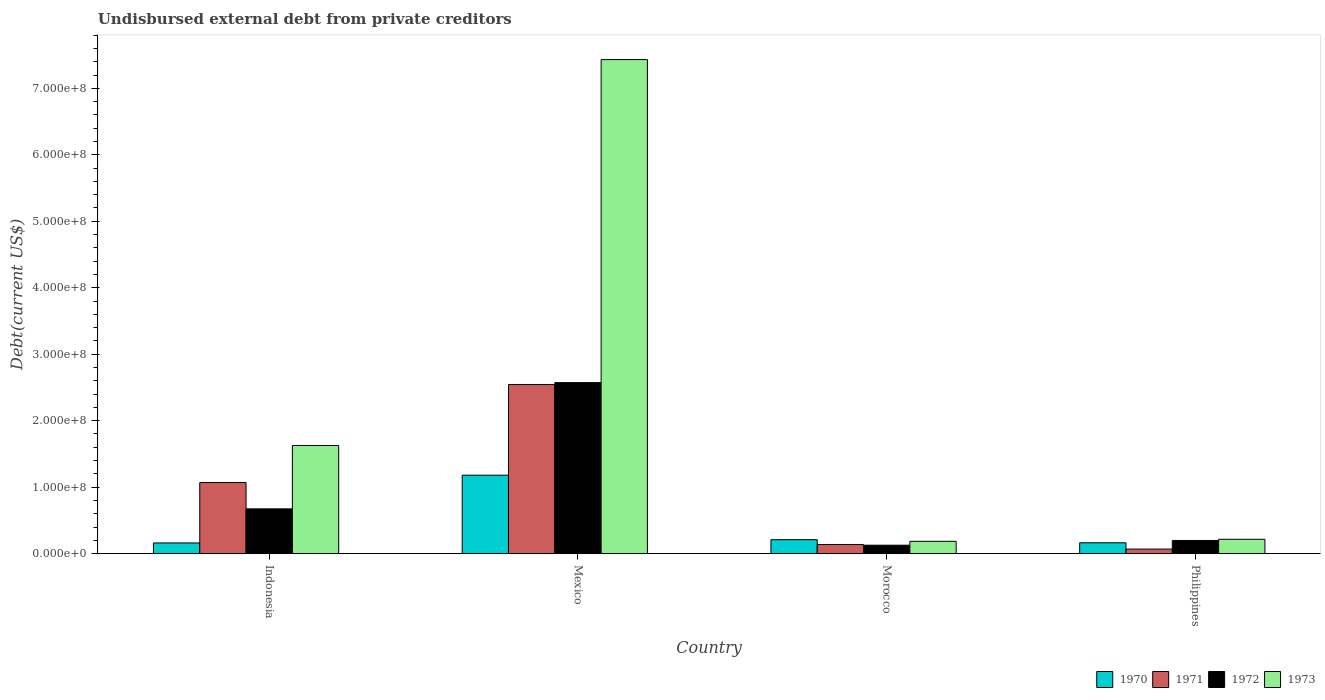Are the number of bars per tick equal to the number of legend labels?
Make the answer very short. Yes. Are the number of bars on each tick of the X-axis equal?
Offer a very short reply. Yes. How many bars are there on the 2nd tick from the right?
Your answer should be very brief. 4. What is the label of the 1st group of bars from the left?
Your answer should be compact. Indonesia. What is the total debt in 1970 in Indonesia?
Offer a very short reply. 1.61e+07. Across all countries, what is the maximum total debt in 1971?
Provide a short and direct response. 2.54e+08. Across all countries, what is the minimum total debt in 1973?
Offer a terse response. 1.86e+07. In which country was the total debt in 1973 maximum?
Provide a succinct answer. Mexico. What is the total total debt in 1972 in the graph?
Ensure brevity in your answer.  3.57e+08. What is the difference between the total debt in 1972 in Indonesia and that in Philippines?
Offer a very short reply. 4.75e+07. What is the difference between the total debt in 1971 in Indonesia and the total debt in 1973 in Mexico?
Give a very brief answer. -6.36e+08. What is the average total debt in 1970 per country?
Ensure brevity in your answer.  4.29e+07. What is the difference between the total debt of/in 1973 and total debt of/in 1971 in Morocco?
Keep it short and to the point. 4.81e+06. In how many countries, is the total debt in 1970 greater than 40000000 US$?
Your answer should be compact. 1. What is the ratio of the total debt in 1972 in Indonesia to that in Philippines?
Make the answer very short. 3.39. What is the difference between the highest and the second highest total debt in 1971?
Your answer should be compact. 2.41e+08. What is the difference between the highest and the lowest total debt in 1970?
Offer a very short reply. 1.02e+08. Is the sum of the total debt in 1970 in Mexico and Philippines greater than the maximum total debt in 1972 across all countries?
Make the answer very short. No. Is it the case that in every country, the sum of the total debt in 1972 and total debt in 1973 is greater than the sum of total debt in 1970 and total debt in 1971?
Offer a terse response. Yes. What does the 1st bar from the left in Philippines represents?
Your answer should be very brief. 1970. What does the 2nd bar from the right in Philippines represents?
Your response must be concise. 1972. How many bars are there?
Your answer should be very brief. 16. Are all the bars in the graph horizontal?
Provide a short and direct response. No. Are the values on the major ticks of Y-axis written in scientific E-notation?
Offer a very short reply. Yes. How are the legend labels stacked?
Your answer should be very brief. Horizontal. What is the title of the graph?
Your answer should be compact. Undisbursed external debt from private creditors. Does "1974" appear as one of the legend labels in the graph?
Provide a succinct answer. No. What is the label or title of the X-axis?
Your response must be concise. Country. What is the label or title of the Y-axis?
Your answer should be very brief. Debt(current US$). What is the Debt(current US$) of 1970 in Indonesia?
Offer a very short reply. 1.61e+07. What is the Debt(current US$) of 1971 in Indonesia?
Ensure brevity in your answer.  1.07e+08. What is the Debt(current US$) of 1972 in Indonesia?
Offer a very short reply. 6.74e+07. What is the Debt(current US$) of 1973 in Indonesia?
Offer a very short reply. 1.63e+08. What is the Debt(current US$) of 1970 in Mexico?
Give a very brief answer. 1.18e+08. What is the Debt(current US$) in 1971 in Mexico?
Keep it short and to the point. 2.54e+08. What is the Debt(current US$) of 1972 in Mexico?
Offer a very short reply. 2.57e+08. What is the Debt(current US$) of 1973 in Mexico?
Offer a very short reply. 7.43e+08. What is the Debt(current US$) of 1970 in Morocco?
Keep it short and to the point. 2.10e+07. What is the Debt(current US$) of 1971 in Morocco?
Your answer should be compact. 1.37e+07. What is the Debt(current US$) of 1972 in Morocco?
Make the answer very short. 1.27e+07. What is the Debt(current US$) of 1973 in Morocco?
Offer a very short reply. 1.86e+07. What is the Debt(current US$) of 1970 in Philippines?
Make the answer very short. 1.64e+07. What is the Debt(current US$) in 1971 in Philippines?
Your response must be concise. 6.87e+06. What is the Debt(current US$) of 1972 in Philippines?
Provide a succinct answer. 1.99e+07. What is the Debt(current US$) in 1973 in Philippines?
Your response must be concise. 2.16e+07. Across all countries, what is the maximum Debt(current US$) in 1970?
Provide a short and direct response. 1.18e+08. Across all countries, what is the maximum Debt(current US$) in 1971?
Offer a very short reply. 2.54e+08. Across all countries, what is the maximum Debt(current US$) in 1972?
Offer a very short reply. 2.57e+08. Across all countries, what is the maximum Debt(current US$) of 1973?
Your answer should be compact. 7.43e+08. Across all countries, what is the minimum Debt(current US$) of 1970?
Provide a succinct answer. 1.61e+07. Across all countries, what is the minimum Debt(current US$) in 1971?
Keep it short and to the point. 6.87e+06. Across all countries, what is the minimum Debt(current US$) of 1972?
Your answer should be compact. 1.27e+07. Across all countries, what is the minimum Debt(current US$) of 1973?
Keep it short and to the point. 1.86e+07. What is the total Debt(current US$) of 1970 in the graph?
Your response must be concise. 1.72e+08. What is the total Debt(current US$) in 1971 in the graph?
Your response must be concise. 3.82e+08. What is the total Debt(current US$) of 1972 in the graph?
Provide a succinct answer. 3.57e+08. What is the total Debt(current US$) in 1973 in the graph?
Provide a succinct answer. 9.46e+08. What is the difference between the Debt(current US$) of 1970 in Indonesia and that in Mexico?
Keep it short and to the point. -1.02e+08. What is the difference between the Debt(current US$) in 1971 in Indonesia and that in Mexico?
Give a very brief answer. -1.47e+08. What is the difference between the Debt(current US$) in 1972 in Indonesia and that in Mexico?
Provide a succinct answer. -1.90e+08. What is the difference between the Debt(current US$) in 1973 in Indonesia and that in Mexico?
Provide a succinct answer. -5.81e+08. What is the difference between the Debt(current US$) in 1970 in Indonesia and that in Morocco?
Offer a very short reply. -4.89e+06. What is the difference between the Debt(current US$) in 1971 in Indonesia and that in Morocco?
Provide a short and direct response. 9.33e+07. What is the difference between the Debt(current US$) of 1972 in Indonesia and that in Morocco?
Your answer should be compact. 5.46e+07. What is the difference between the Debt(current US$) in 1973 in Indonesia and that in Morocco?
Provide a succinct answer. 1.44e+08. What is the difference between the Debt(current US$) in 1970 in Indonesia and that in Philippines?
Your answer should be compact. -2.28e+05. What is the difference between the Debt(current US$) of 1971 in Indonesia and that in Philippines?
Provide a short and direct response. 1.00e+08. What is the difference between the Debt(current US$) of 1972 in Indonesia and that in Philippines?
Provide a short and direct response. 4.75e+07. What is the difference between the Debt(current US$) in 1973 in Indonesia and that in Philippines?
Make the answer very short. 1.41e+08. What is the difference between the Debt(current US$) in 1970 in Mexico and that in Morocco?
Give a very brief answer. 9.70e+07. What is the difference between the Debt(current US$) in 1971 in Mexico and that in Morocco?
Make the answer very short. 2.41e+08. What is the difference between the Debt(current US$) in 1972 in Mexico and that in Morocco?
Your response must be concise. 2.45e+08. What is the difference between the Debt(current US$) of 1973 in Mexico and that in Morocco?
Your answer should be compact. 7.25e+08. What is the difference between the Debt(current US$) in 1970 in Mexico and that in Philippines?
Offer a terse response. 1.02e+08. What is the difference between the Debt(current US$) of 1971 in Mexico and that in Philippines?
Make the answer very short. 2.48e+08. What is the difference between the Debt(current US$) of 1972 in Mexico and that in Philippines?
Give a very brief answer. 2.37e+08. What is the difference between the Debt(current US$) in 1973 in Mexico and that in Philippines?
Offer a very short reply. 7.22e+08. What is the difference between the Debt(current US$) in 1970 in Morocco and that in Philippines?
Provide a succinct answer. 4.66e+06. What is the difference between the Debt(current US$) of 1971 in Morocco and that in Philippines?
Your answer should be compact. 6.88e+06. What is the difference between the Debt(current US$) of 1972 in Morocco and that in Philippines?
Provide a short and direct response. -7.12e+06. What is the difference between the Debt(current US$) of 1973 in Morocco and that in Philippines?
Provide a short and direct response. -3.06e+06. What is the difference between the Debt(current US$) of 1970 in Indonesia and the Debt(current US$) of 1971 in Mexico?
Give a very brief answer. -2.38e+08. What is the difference between the Debt(current US$) of 1970 in Indonesia and the Debt(current US$) of 1972 in Mexico?
Provide a succinct answer. -2.41e+08. What is the difference between the Debt(current US$) of 1970 in Indonesia and the Debt(current US$) of 1973 in Mexico?
Your answer should be compact. -7.27e+08. What is the difference between the Debt(current US$) in 1971 in Indonesia and the Debt(current US$) in 1972 in Mexico?
Make the answer very short. -1.50e+08. What is the difference between the Debt(current US$) of 1971 in Indonesia and the Debt(current US$) of 1973 in Mexico?
Offer a very short reply. -6.36e+08. What is the difference between the Debt(current US$) of 1972 in Indonesia and the Debt(current US$) of 1973 in Mexico?
Your answer should be very brief. -6.76e+08. What is the difference between the Debt(current US$) of 1970 in Indonesia and the Debt(current US$) of 1971 in Morocco?
Make the answer very short. 2.38e+06. What is the difference between the Debt(current US$) in 1970 in Indonesia and the Debt(current US$) in 1972 in Morocco?
Your answer should be compact. 3.39e+06. What is the difference between the Debt(current US$) in 1970 in Indonesia and the Debt(current US$) in 1973 in Morocco?
Offer a terse response. -2.44e+06. What is the difference between the Debt(current US$) in 1971 in Indonesia and the Debt(current US$) in 1972 in Morocco?
Your answer should be very brief. 9.43e+07. What is the difference between the Debt(current US$) of 1971 in Indonesia and the Debt(current US$) of 1973 in Morocco?
Ensure brevity in your answer.  8.85e+07. What is the difference between the Debt(current US$) of 1972 in Indonesia and the Debt(current US$) of 1973 in Morocco?
Give a very brief answer. 4.88e+07. What is the difference between the Debt(current US$) in 1970 in Indonesia and the Debt(current US$) in 1971 in Philippines?
Make the answer very short. 9.25e+06. What is the difference between the Debt(current US$) in 1970 in Indonesia and the Debt(current US$) in 1972 in Philippines?
Offer a terse response. -3.73e+06. What is the difference between the Debt(current US$) in 1970 in Indonesia and the Debt(current US$) in 1973 in Philippines?
Provide a succinct answer. -5.49e+06. What is the difference between the Debt(current US$) in 1971 in Indonesia and the Debt(current US$) in 1972 in Philippines?
Keep it short and to the point. 8.72e+07. What is the difference between the Debt(current US$) in 1971 in Indonesia and the Debt(current US$) in 1973 in Philippines?
Your response must be concise. 8.54e+07. What is the difference between the Debt(current US$) in 1972 in Indonesia and the Debt(current US$) in 1973 in Philippines?
Ensure brevity in your answer.  4.58e+07. What is the difference between the Debt(current US$) in 1970 in Mexico and the Debt(current US$) in 1971 in Morocco?
Your response must be concise. 1.04e+08. What is the difference between the Debt(current US$) of 1970 in Mexico and the Debt(current US$) of 1972 in Morocco?
Provide a succinct answer. 1.05e+08. What is the difference between the Debt(current US$) in 1970 in Mexico and the Debt(current US$) in 1973 in Morocco?
Your response must be concise. 9.95e+07. What is the difference between the Debt(current US$) in 1971 in Mexico and the Debt(current US$) in 1972 in Morocco?
Give a very brief answer. 2.42e+08. What is the difference between the Debt(current US$) of 1971 in Mexico and the Debt(current US$) of 1973 in Morocco?
Provide a succinct answer. 2.36e+08. What is the difference between the Debt(current US$) of 1972 in Mexico and the Debt(current US$) of 1973 in Morocco?
Offer a terse response. 2.39e+08. What is the difference between the Debt(current US$) in 1970 in Mexico and the Debt(current US$) in 1971 in Philippines?
Provide a succinct answer. 1.11e+08. What is the difference between the Debt(current US$) in 1970 in Mexico and the Debt(current US$) in 1972 in Philippines?
Your answer should be compact. 9.82e+07. What is the difference between the Debt(current US$) of 1970 in Mexico and the Debt(current US$) of 1973 in Philippines?
Make the answer very short. 9.64e+07. What is the difference between the Debt(current US$) of 1971 in Mexico and the Debt(current US$) of 1972 in Philippines?
Provide a succinct answer. 2.35e+08. What is the difference between the Debt(current US$) in 1971 in Mexico and the Debt(current US$) in 1973 in Philippines?
Provide a succinct answer. 2.33e+08. What is the difference between the Debt(current US$) in 1972 in Mexico and the Debt(current US$) in 1973 in Philippines?
Provide a succinct answer. 2.36e+08. What is the difference between the Debt(current US$) of 1970 in Morocco and the Debt(current US$) of 1971 in Philippines?
Keep it short and to the point. 1.41e+07. What is the difference between the Debt(current US$) in 1970 in Morocco and the Debt(current US$) in 1972 in Philippines?
Offer a very short reply. 1.16e+06. What is the difference between the Debt(current US$) of 1970 in Morocco and the Debt(current US$) of 1973 in Philippines?
Offer a very short reply. -6.03e+05. What is the difference between the Debt(current US$) of 1971 in Morocco and the Debt(current US$) of 1972 in Philippines?
Keep it short and to the point. -6.10e+06. What is the difference between the Debt(current US$) of 1971 in Morocco and the Debt(current US$) of 1973 in Philippines?
Keep it short and to the point. -7.87e+06. What is the difference between the Debt(current US$) of 1972 in Morocco and the Debt(current US$) of 1973 in Philippines?
Your answer should be very brief. -8.88e+06. What is the average Debt(current US$) of 1970 per country?
Offer a terse response. 4.29e+07. What is the average Debt(current US$) of 1971 per country?
Keep it short and to the point. 9.55e+07. What is the average Debt(current US$) in 1972 per country?
Offer a terse response. 8.93e+07. What is the average Debt(current US$) of 1973 per country?
Your response must be concise. 2.37e+08. What is the difference between the Debt(current US$) in 1970 and Debt(current US$) in 1971 in Indonesia?
Make the answer very short. -9.09e+07. What is the difference between the Debt(current US$) of 1970 and Debt(current US$) of 1972 in Indonesia?
Provide a short and direct response. -5.12e+07. What is the difference between the Debt(current US$) in 1970 and Debt(current US$) in 1973 in Indonesia?
Your answer should be compact. -1.47e+08. What is the difference between the Debt(current US$) in 1971 and Debt(current US$) in 1972 in Indonesia?
Offer a terse response. 3.96e+07. What is the difference between the Debt(current US$) of 1971 and Debt(current US$) of 1973 in Indonesia?
Make the answer very short. -5.57e+07. What is the difference between the Debt(current US$) of 1972 and Debt(current US$) of 1973 in Indonesia?
Your answer should be very brief. -9.53e+07. What is the difference between the Debt(current US$) of 1970 and Debt(current US$) of 1971 in Mexico?
Your response must be concise. -1.36e+08. What is the difference between the Debt(current US$) in 1970 and Debt(current US$) in 1972 in Mexico?
Your answer should be very brief. -1.39e+08. What is the difference between the Debt(current US$) of 1970 and Debt(current US$) of 1973 in Mexico?
Provide a succinct answer. -6.25e+08. What is the difference between the Debt(current US$) of 1971 and Debt(current US$) of 1972 in Mexico?
Your answer should be compact. -2.84e+06. What is the difference between the Debt(current US$) of 1971 and Debt(current US$) of 1973 in Mexico?
Your answer should be compact. -4.89e+08. What is the difference between the Debt(current US$) of 1972 and Debt(current US$) of 1973 in Mexico?
Your answer should be compact. -4.86e+08. What is the difference between the Debt(current US$) in 1970 and Debt(current US$) in 1971 in Morocco?
Offer a terse response. 7.27e+06. What is the difference between the Debt(current US$) in 1970 and Debt(current US$) in 1972 in Morocco?
Give a very brief answer. 8.28e+06. What is the difference between the Debt(current US$) in 1970 and Debt(current US$) in 1973 in Morocco?
Make the answer very short. 2.45e+06. What is the difference between the Debt(current US$) of 1971 and Debt(current US$) of 1972 in Morocco?
Give a very brief answer. 1.01e+06. What is the difference between the Debt(current US$) of 1971 and Debt(current US$) of 1973 in Morocco?
Give a very brief answer. -4.81e+06. What is the difference between the Debt(current US$) of 1972 and Debt(current US$) of 1973 in Morocco?
Offer a very short reply. -5.82e+06. What is the difference between the Debt(current US$) in 1970 and Debt(current US$) in 1971 in Philippines?
Your answer should be compact. 9.48e+06. What is the difference between the Debt(current US$) of 1970 and Debt(current US$) of 1972 in Philippines?
Ensure brevity in your answer.  -3.50e+06. What is the difference between the Debt(current US$) in 1970 and Debt(current US$) in 1973 in Philippines?
Keep it short and to the point. -5.27e+06. What is the difference between the Debt(current US$) of 1971 and Debt(current US$) of 1972 in Philippines?
Give a very brief answer. -1.30e+07. What is the difference between the Debt(current US$) of 1971 and Debt(current US$) of 1973 in Philippines?
Provide a succinct answer. -1.47e+07. What is the difference between the Debt(current US$) of 1972 and Debt(current US$) of 1973 in Philippines?
Give a very brief answer. -1.76e+06. What is the ratio of the Debt(current US$) of 1970 in Indonesia to that in Mexico?
Ensure brevity in your answer.  0.14. What is the ratio of the Debt(current US$) in 1971 in Indonesia to that in Mexico?
Your answer should be compact. 0.42. What is the ratio of the Debt(current US$) in 1972 in Indonesia to that in Mexico?
Your response must be concise. 0.26. What is the ratio of the Debt(current US$) of 1973 in Indonesia to that in Mexico?
Offer a very short reply. 0.22. What is the ratio of the Debt(current US$) in 1970 in Indonesia to that in Morocco?
Your answer should be very brief. 0.77. What is the ratio of the Debt(current US$) in 1971 in Indonesia to that in Morocco?
Keep it short and to the point. 7.78. What is the ratio of the Debt(current US$) in 1972 in Indonesia to that in Morocco?
Give a very brief answer. 5.29. What is the ratio of the Debt(current US$) of 1973 in Indonesia to that in Morocco?
Your answer should be very brief. 8.77. What is the ratio of the Debt(current US$) of 1970 in Indonesia to that in Philippines?
Ensure brevity in your answer.  0.99. What is the ratio of the Debt(current US$) of 1971 in Indonesia to that in Philippines?
Provide a succinct answer. 15.57. What is the ratio of the Debt(current US$) of 1972 in Indonesia to that in Philippines?
Give a very brief answer. 3.39. What is the ratio of the Debt(current US$) of 1973 in Indonesia to that in Philippines?
Offer a very short reply. 7.53. What is the ratio of the Debt(current US$) of 1970 in Mexico to that in Morocco?
Ensure brevity in your answer.  5.62. What is the ratio of the Debt(current US$) of 1971 in Mexico to that in Morocco?
Your answer should be very brief. 18.51. What is the ratio of the Debt(current US$) of 1972 in Mexico to that in Morocco?
Keep it short and to the point. 20.2. What is the ratio of the Debt(current US$) in 1973 in Mexico to that in Morocco?
Make the answer very short. 40.04. What is the ratio of the Debt(current US$) in 1970 in Mexico to that in Philippines?
Provide a short and direct response. 7.22. What is the ratio of the Debt(current US$) of 1971 in Mexico to that in Philippines?
Provide a succinct answer. 37.02. What is the ratio of the Debt(current US$) of 1972 in Mexico to that in Philippines?
Keep it short and to the point. 12.96. What is the ratio of the Debt(current US$) of 1973 in Mexico to that in Philippines?
Keep it short and to the point. 34.38. What is the ratio of the Debt(current US$) of 1970 in Morocco to that in Philippines?
Provide a succinct answer. 1.29. What is the ratio of the Debt(current US$) in 1971 in Morocco to that in Philippines?
Your answer should be compact. 2. What is the ratio of the Debt(current US$) of 1972 in Morocco to that in Philippines?
Offer a very short reply. 0.64. What is the ratio of the Debt(current US$) of 1973 in Morocco to that in Philippines?
Your answer should be compact. 0.86. What is the difference between the highest and the second highest Debt(current US$) in 1970?
Your response must be concise. 9.70e+07. What is the difference between the highest and the second highest Debt(current US$) of 1971?
Provide a short and direct response. 1.47e+08. What is the difference between the highest and the second highest Debt(current US$) of 1972?
Ensure brevity in your answer.  1.90e+08. What is the difference between the highest and the second highest Debt(current US$) in 1973?
Ensure brevity in your answer.  5.81e+08. What is the difference between the highest and the lowest Debt(current US$) in 1970?
Your answer should be compact. 1.02e+08. What is the difference between the highest and the lowest Debt(current US$) of 1971?
Provide a short and direct response. 2.48e+08. What is the difference between the highest and the lowest Debt(current US$) in 1972?
Provide a succinct answer. 2.45e+08. What is the difference between the highest and the lowest Debt(current US$) of 1973?
Provide a succinct answer. 7.25e+08. 